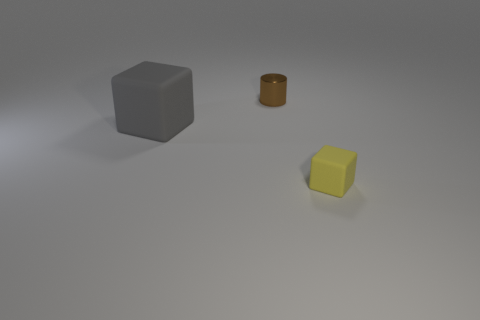Are any objects visible?
Offer a terse response. Yes. There is a object in front of the gray matte thing; what shape is it?
Your answer should be compact. Cube. What number of objects are on the right side of the tiny cylinder and behind the big matte cube?
Your answer should be very brief. 0. How many other things are the same size as the gray thing?
Offer a terse response. 0. There is a small thing that is behind the large gray thing; is its shape the same as the rubber object on the left side of the small rubber block?
Ensure brevity in your answer.  No. What number of objects are either green matte balls or matte blocks behind the yellow cube?
Provide a short and direct response. 1. What is the material of the thing that is right of the big gray block and behind the small yellow thing?
Your answer should be compact. Metal. Is there anything else that has the same shape as the big rubber thing?
Offer a terse response. Yes. There is a large cube that is the same material as the tiny cube; what color is it?
Your answer should be compact. Gray. How many things are small brown metallic objects or small brown balls?
Offer a very short reply. 1. 